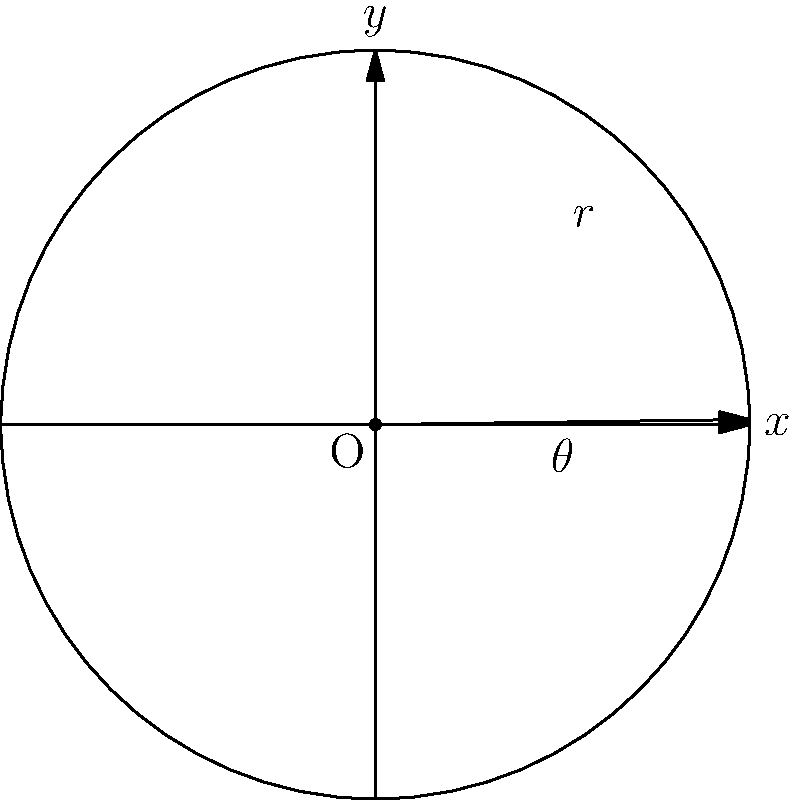For the upcoming One Direction reunion concert, you're planning to launch a special holographic stage prop. The prop needs to be launched at a specific angle and distance for maximum visual impact. Using polar coordinates, if the prop is launched at an angle of $\frac{\pi}{4}$ radians and travels a distance of 15 meters, what are its Cartesian coordinates $(x,y)$ on the stage? To solve this problem, we need to convert from polar coordinates $(r,\theta)$ to Cartesian coordinates $(x,y)$. Here's how we do it:

1) Given:
   - Angle $\theta = \frac{\pi}{4}$ radians
   - Distance $r = 15$ meters

2) The conversion formulas from polar to Cartesian coordinates are:
   $x = r \cos(\theta)$
   $y = r \sin(\theta)$

3) Let's calculate $x$:
   $x = 15 \cos(\frac{\pi}{4})$
   $\cos(\frac{\pi}{4}) = \frac{\sqrt{2}}{2}$
   $x = 15 \cdot \frac{\sqrt{2}}{2} = \frac{15\sqrt{2}}{2} \approx 10.61$ meters

4) Now let's calculate $y$:
   $y = 15 \sin(\frac{\pi}{4})$
   $\sin(\frac{\pi}{4}) = \frac{\sqrt{2}}{2}$
   $y = 15 \cdot \frac{\sqrt{2}}{2} = \frac{15\sqrt{2}}{2} \approx 10.61$ meters

5) Therefore, the Cartesian coordinates are $(x,y) = (\frac{15\sqrt{2}}{2}, \frac{15\sqrt{2}}{2})$
Answer: $(\frac{15\sqrt{2}}{2}, \frac{15\sqrt{2}}{2})$ 